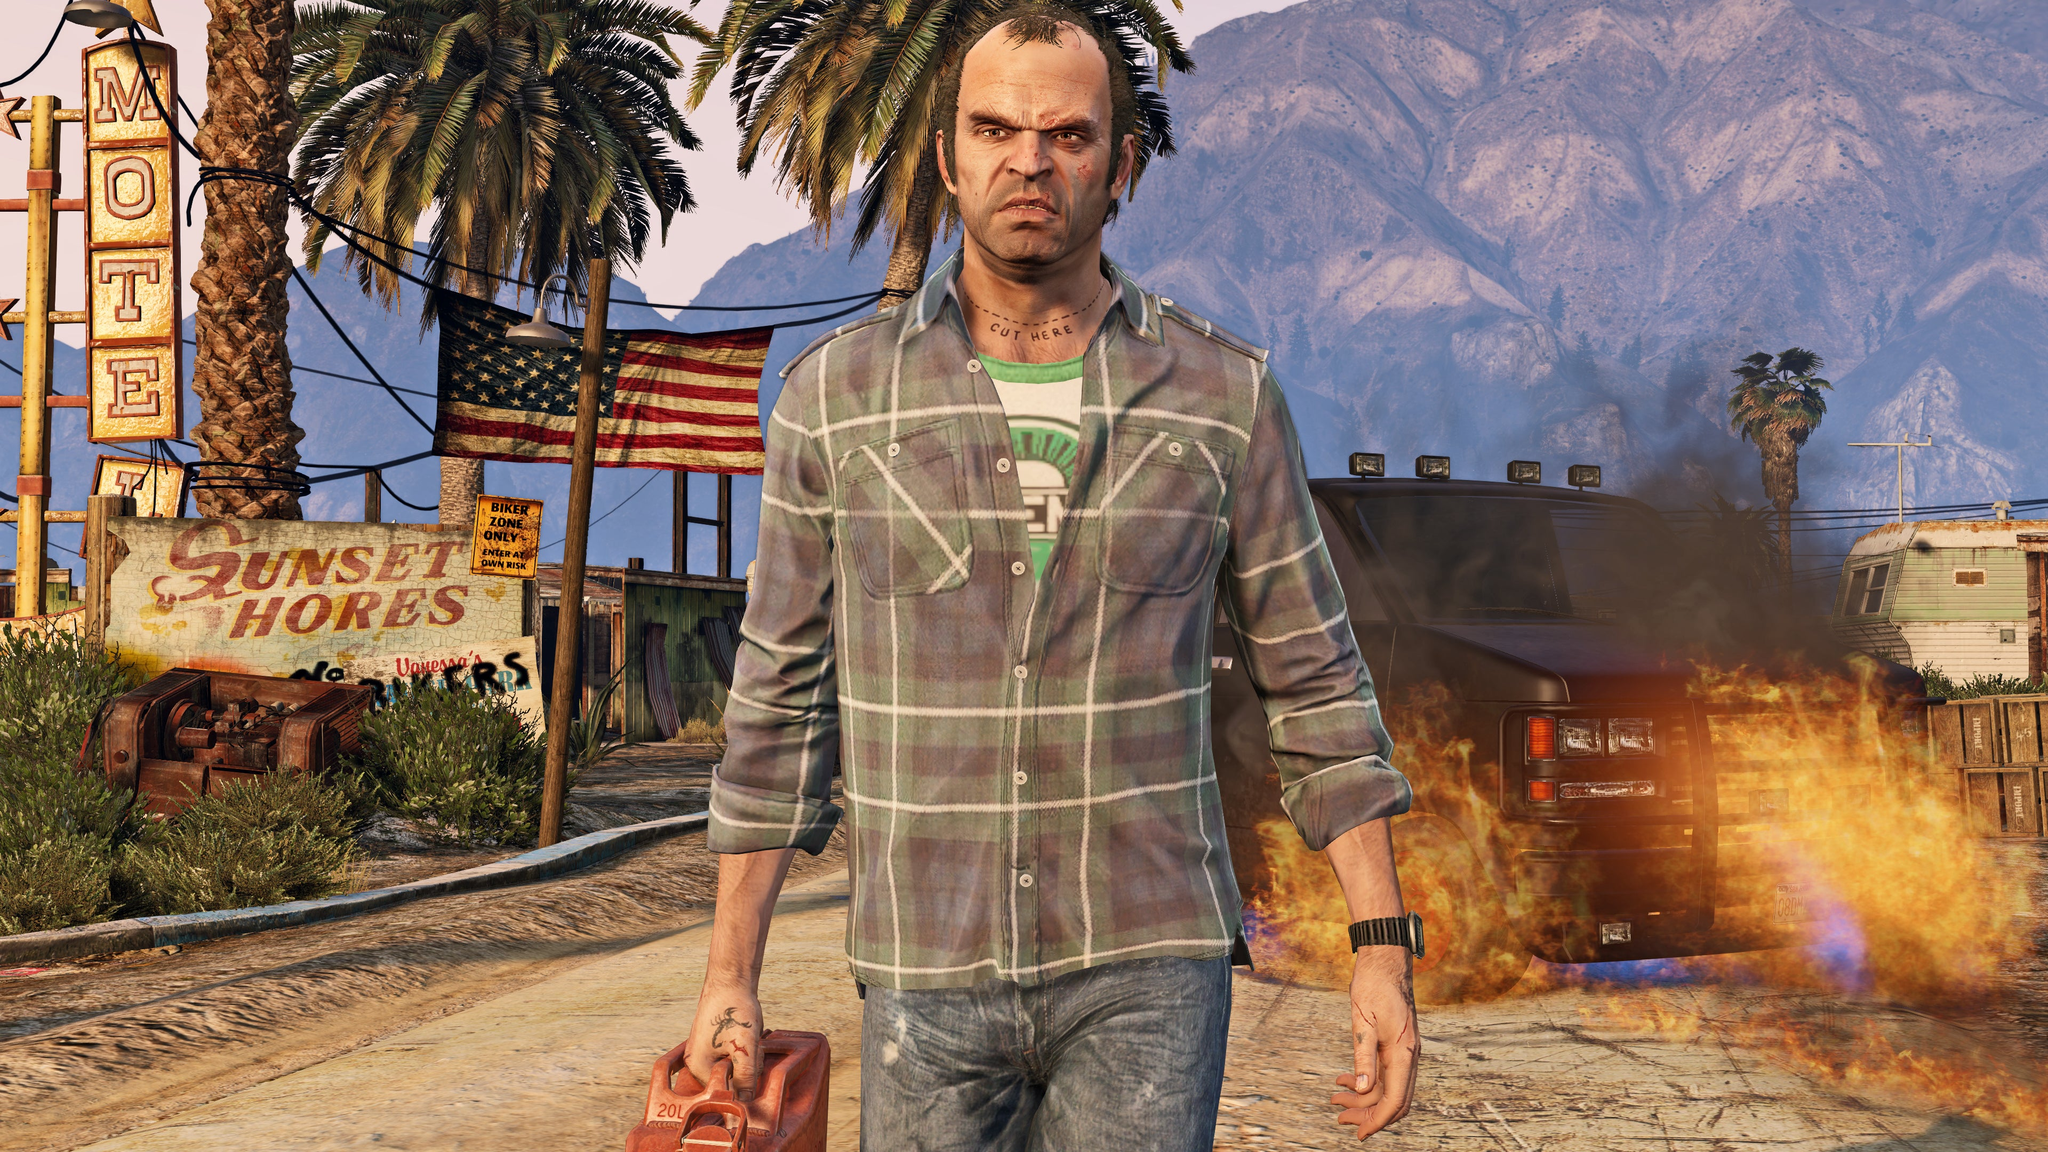Imagine this image is part of a movie. What genre do you think the movie belongs to and why? This image gives off strong vibes of a thriller or action movie with elements of a dystopian context. The character's intense look, the rundown and abandoned surroundings, and the unsettling presence of an unsupervised fire suggest a plot filled with suspense, danger, and survival. The elements in the image imply themes of rebellion, lawlessness, and perhaps a fight against overwhelming odds, all typical of a gripping action thriller or a dystopian film. What could be an interesting plot twist for this movie? An intriguing plot twist for this movie could be the revelation that the character is not a villain or outlaw as initially perceived but rather an undercover agent or a former resident seeking to reclaim and rebuild the area. The gas can he carries could be meant for a controlled fire aimed at clearing out the chaos brought by rival gangs or corrupt officials. This twist adds depth to his story, portraying him as a complex hero fighting against the true antagonists causing the area's decline. 